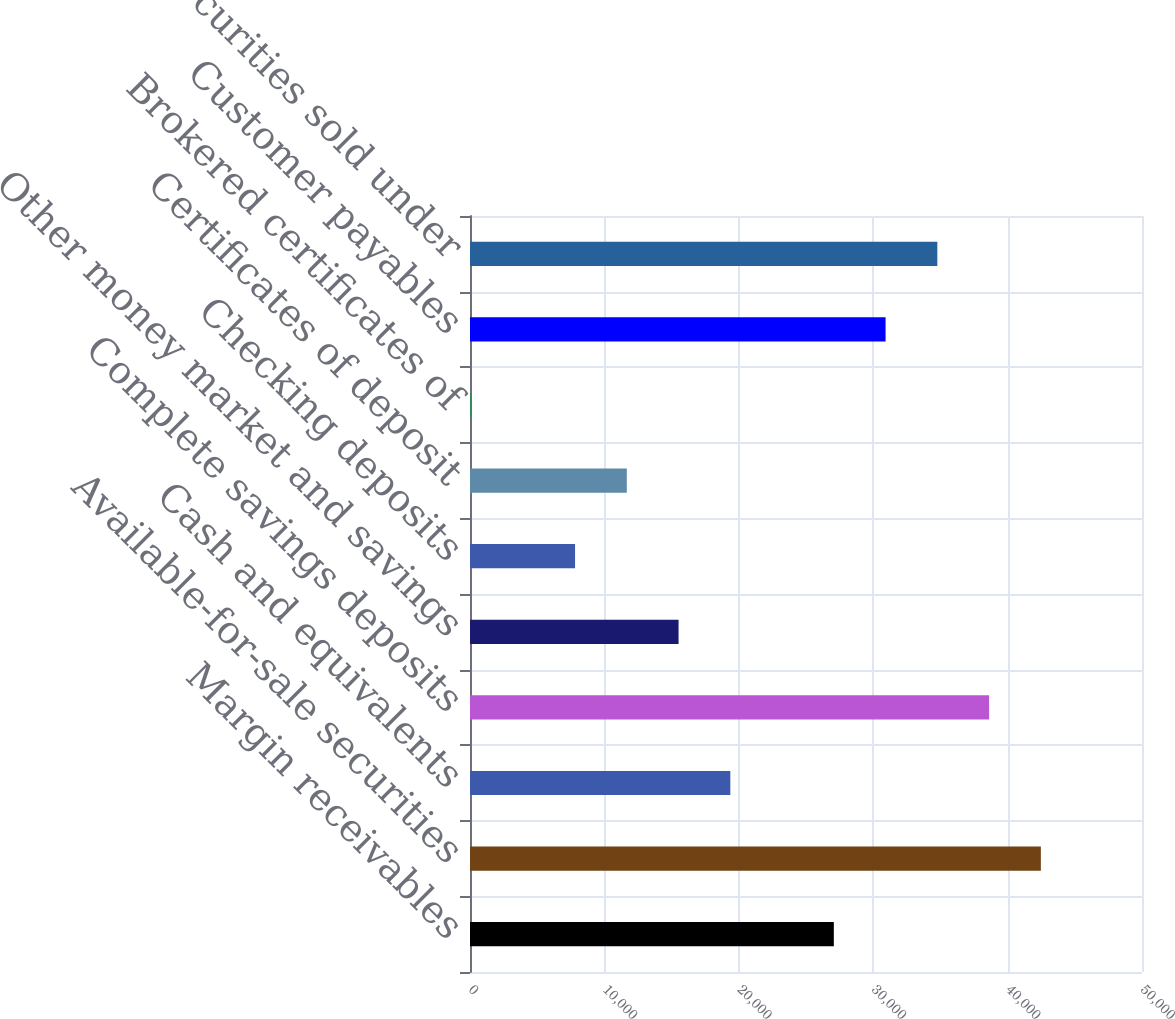<chart> <loc_0><loc_0><loc_500><loc_500><bar_chart><fcel>Margin receivables<fcel>Available-for-sale securities<fcel>Cash and equivalents<fcel>Complete savings deposits<fcel>Other money market and savings<fcel>Checking deposits<fcel>Certificates of deposit<fcel>Brokered certificates of<fcel>Customer payables<fcel>Securities sold under<nl><fcel>27070.5<fcel>42473.4<fcel>19369<fcel>38622.7<fcel>15518.3<fcel>7816.78<fcel>11667.5<fcel>115.3<fcel>30921.2<fcel>34772<nl></chart> 